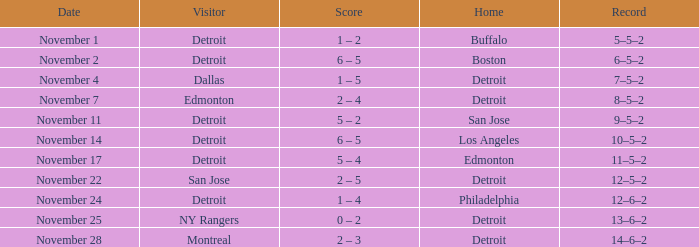Which guest owns a home in los angeles? Detroit. 